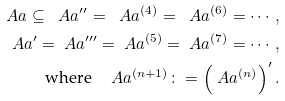<formula> <loc_0><loc_0><loc_500><loc_500>\ A a \subseteq \ A a ^ { \prime \prime } = \ A a ^ { ( 4 ) } = \ A a ^ { ( 6 ) } = \cdots , \\ \ A a ^ { \prime } = \ A a ^ { \prime \prime \prime } = \ A a ^ { ( 5 ) } = \ A a ^ { ( 7 ) } = \cdots , \\ \text {where} \quad \ A a ^ { ( n + 1 ) } \colon = \left ( \ A a ^ { ( n ) } \right ) ^ { \prime } .</formula> 